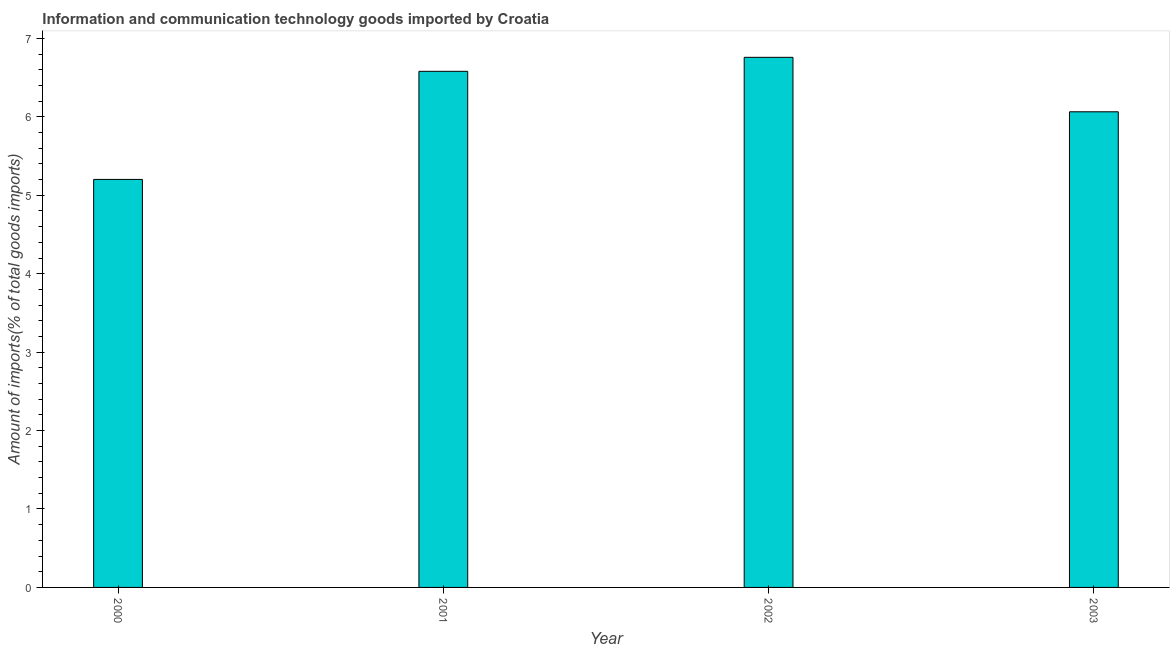Does the graph contain any zero values?
Offer a terse response. No. What is the title of the graph?
Offer a terse response. Information and communication technology goods imported by Croatia. What is the label or title of the X-axis?
Offer a very short reply. Year. What is the label or title of the Y-axis?
Provide a short and direct response. Amount of imports(% of total goods imports). What is the amount of ict goods imports in 2000?
Provide a succinct answer. 5.2. Across all years, what is the maximum amount of ict goods imports?
Ensure brevity in your answer.  6.76. Across all years, what is the minimum amount of ict goods imports?
Give a very brief answer. 5.2. In which year was the amount of ict goods imports maximum?
Your response must be concise. 2002. In which year was the amount of ict goods imports minimum?
Ensure brevity in your answer.  2000. What is the sum of the amount of ict goods imports?
Make the answer very short. 24.61. What is the difference between the amount of ict goods imports in 2000 and 2001?
Ensure brevity in your answer.  -1.38. What is the average amount of ict goods imports per year?
Provide a short and direct response. 6.15. What is the median amount of ict goods imports?
Offer a very short reply. 6.32. What is the ratio of the amount of ict goods imports in 2000 to that in 2001?
Keep it short and to the point. 0.79. What is the difference between the highest and the second highest amount of ict goods imports?
Make the answer very short. 0.18. What is the difference between the highest and the lowest amount of ict goods imports?
Offer a terse response. 1.56. How many years are there in the graph?
Your answer should be very brief. 4. Are the values on the major ticks of Y-axis written in scientific E-notation?
Your answer should be very brief. No. What is the Amount of imports(% of total goods imports) in 2000?
Make the answer very short. 5.2. What is the Amount of imports(% of total goods imports) of 2001?
Your answer should be very brief. 6.58. What is the Amount of imports(% of total goods imports) in 2002?
Make the answer very short. 6.76. What is the Amount of imports(% of total goods imports) of 2003?
Keep it short and to the point. 6.06. What is the difference between the Amount of imports(% of total goods imports) in 2000 and 2001?
Give a very brief answer. -1.38. What is the difference between the Amount of imports(% of total goods imports) in 2000 and 2002?
Your response must be concise. -1.56. What is the difference between the Amount of imports(% of total goods imports) in 2000 and 2003?
Make the answer very short. -0.86. What is the difference between the Amount of imports(% of total goods imports) in 2001 and 2002?
Your answer should be very brief. -0.18. What is the difference between the Amount of imports(% of total goods imports) in 2001 and 2003?
Keep it short and to the point. 0.52. What is the difference between the Amount of imports(% of total goods imports) in 2002 and 2003?
Make the answer very short. 0.69. What is the ratio of the Amount of imports(% of total goods imports) in 2000 to that in 2001?
Ensure brevity in your answer.  0.79. What is the ratio of the Amount of imports(% of total goods imports) in 2000 to that in 2002?
Offer a terse response. 0.77. What is the ratio of the Amount of imports(% of total goods imports) in 2000 to that in 2003?
Offer a very short reply. 0.86. What is the ratio of the Amount of imports(% of total goods imports) in 2001 to that in 2002?
Make the answer very short. 0.97. What is the ratio of the Amount of imports(% of total goods imports) in 2001 to that in 2003?
Your answer should be very brief. 1.08. What is the ratio of the Amount of imports(% of total goods imports) in 2002 to that in 2003?
Make the answer very short. 1.11. 